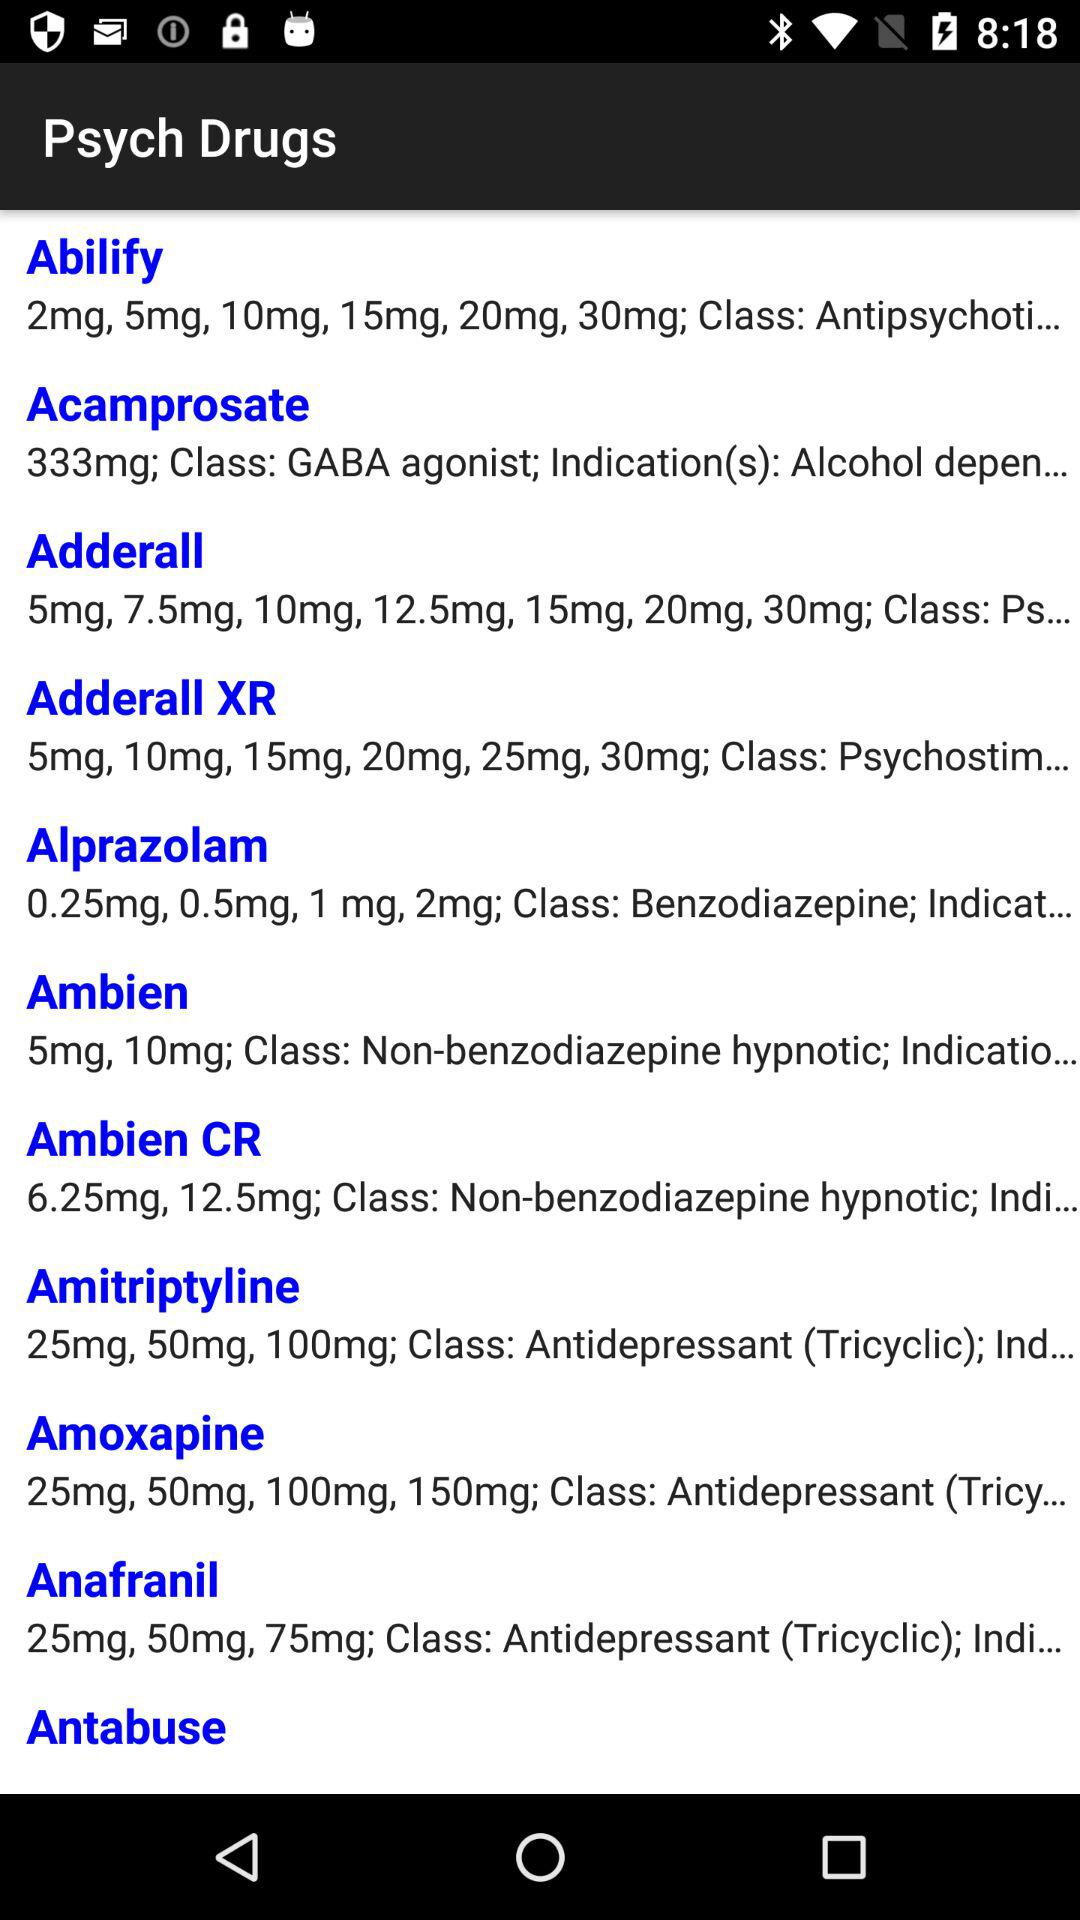What is the class of Adderall psych drugs? The class of Adderall psych drugs is "Ps...". 